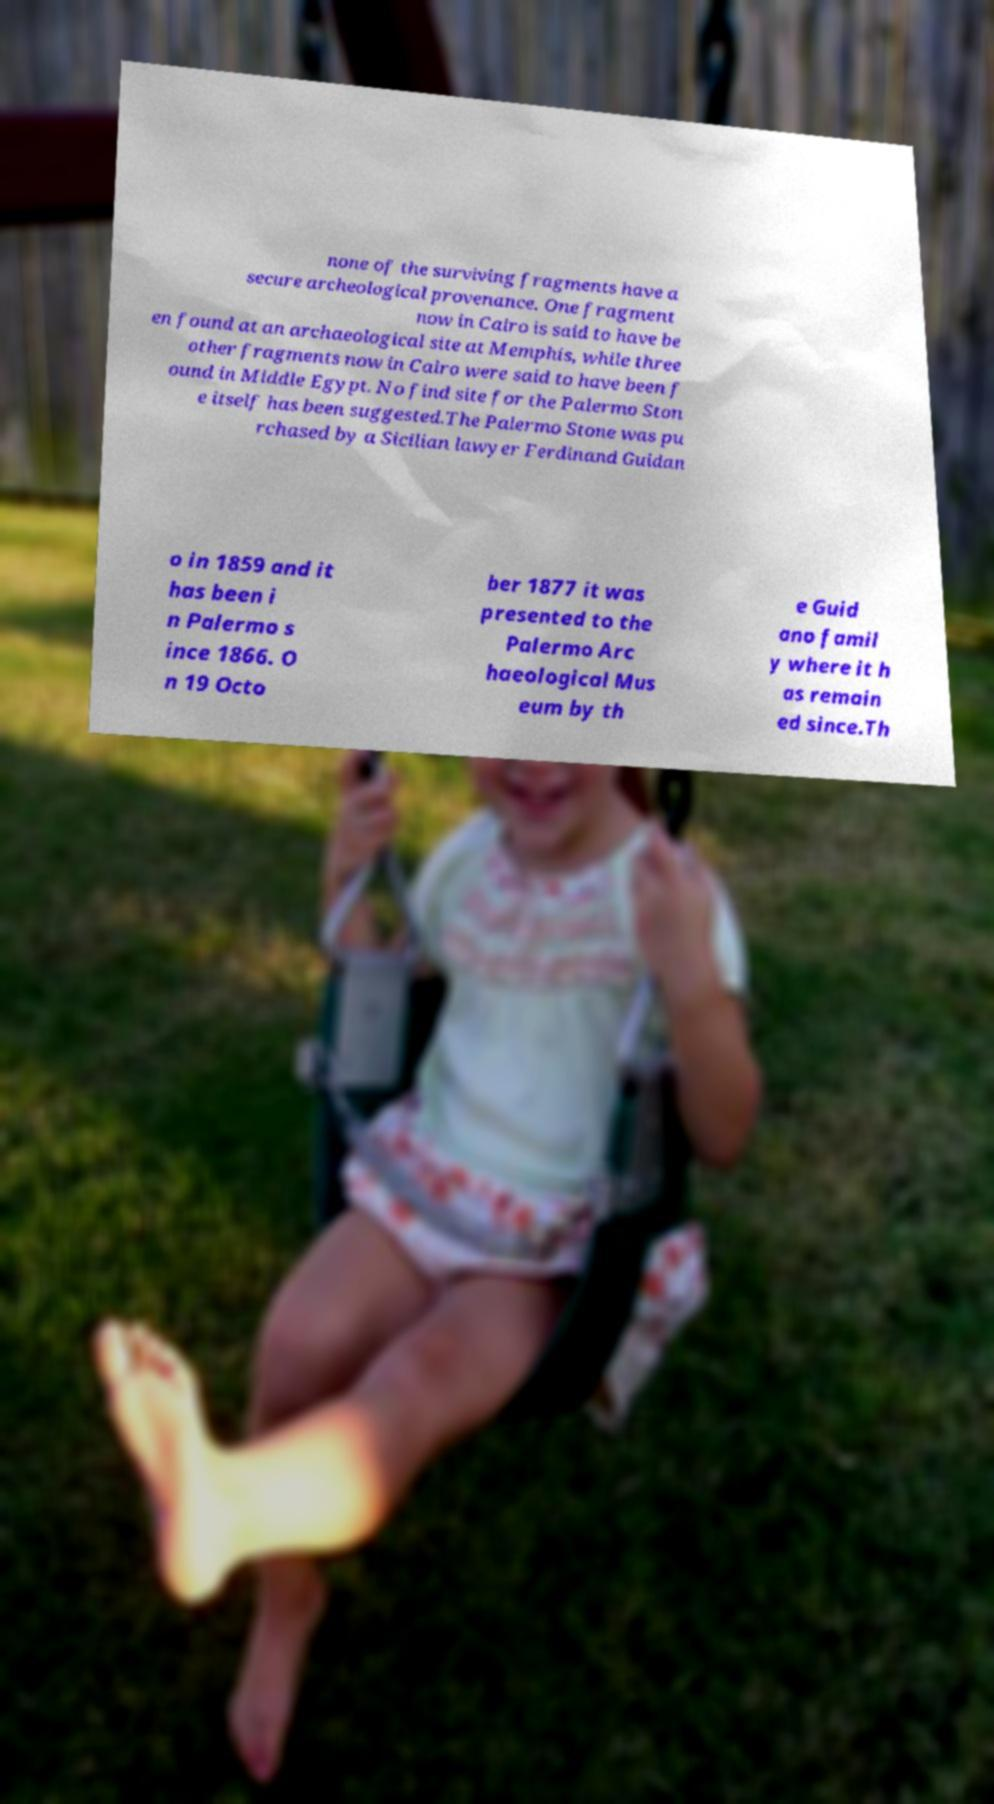Please read and relay the text visible in this image. What does it say? none of the surviving fragments have a secure archeological provenance. One fragment now in Cairo is said to have be en found at an archaeological site at Memphis, while three other fragments now in Cairo were said to have been f ound in Middle Egypt. No find site for the Palermo Ston e itself has been suggested.The Palermo Stone was pu rchased by a Sicilian lawyer Ferdinand Guidan o in 1859 and it has been i n Palermo s ince 1866. O n 19 Octo ber 1877 it was presented to the Palermo Arc haeological Mus eum by th e Guid ano famil y where it h as remain ed since.Th 